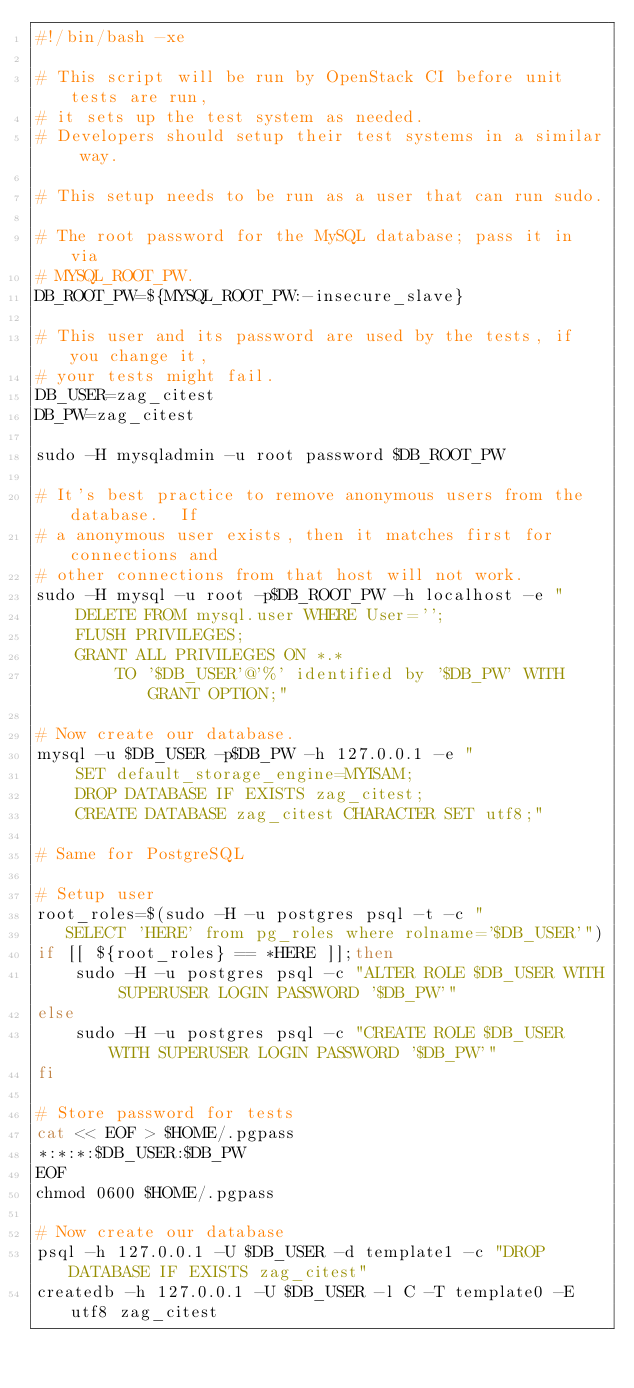<code> <loc_0><loc_0><loc_500><loc_500><_Bash_>#!/bin/bash -xe

# This script will be run by OpenStack CI before unit tests are run,
# it sets up the test system as needed.
# Developers should setup their test systems in a similar way.

# This setup needs to be run as a user that can run sudo.

# The root password for the MySQL database; pass it in via
# MYSQL_ROOT_PW.
DB_ROOT_PW=${MYSQL_ROOT_PW:-insecure_slave}

# This user and its password are used by the tests, if you change it,
# your tests might fail.
DB_USER=zag_citest
DB_PW=zag_citest

sudo -H mysqladmin -u root password $DB_ROOT_PW

# It's best practice to remove anonymous users from the database.  If
# a anonymous user exists, then it matches first for connections and
# other connections from that host will not work.
sudo -H mysql -u root -p$DB_ROOT_PW -h localhost -e "
    DELETE FROM mysql.user WHERE User='';
    FLUSH PRIVILEGES;
    GRANT ALL PRIVILEGES ON *.*
        TO '$DB_USER'@'%' identified by '$DB_PW' WITH GRANT OPTION;"

# Now create our database.
mysql -u $DB_USER -p$DB_PW -h 127.0.0.1 -e "
    SET default_storage_engine=MYISAM;
    DROP DATABASE IF EXISTS zag_citest;
    CREATE DATABASE zag_citest CHARACTER SET utf8;"

# Same for PostgreSQL

# Setup user
root_roles=$(sudo -H -u postgres psql -t -c "
   SELECT 'HERE' from pg_roles where rolname='$DB_USER'")
if [[ ${root_roles} == *HERE ]];then
    sudo -H -u postgres psql -c "ALTER ROLE $DB_USER WITH SUPERUSER LOGIN PASSWORD '$DB_PW'"
else
    sudo -H -u postgres psql -c "CREATE ROLE $DB_USER WITH SUPERUSER LOGIN PASSWORD '$DB_PW'"
fi

# Store password for tests
cat << EOF > $HOME/.pgpass
*:*:*:$DB_USER:$DB_PW
EOF
chmod 0600 $HOME/.pgpass

# Now create our database
psql -h 127.0.0.1 -U $DB_USER -d template1 -c "DROP DATABASE IF EXISTS zag_citest"
createdb -h 127.0.0.1 -U $DB_USER -l C -T template0 -E utf8 zag_citest
</code> 